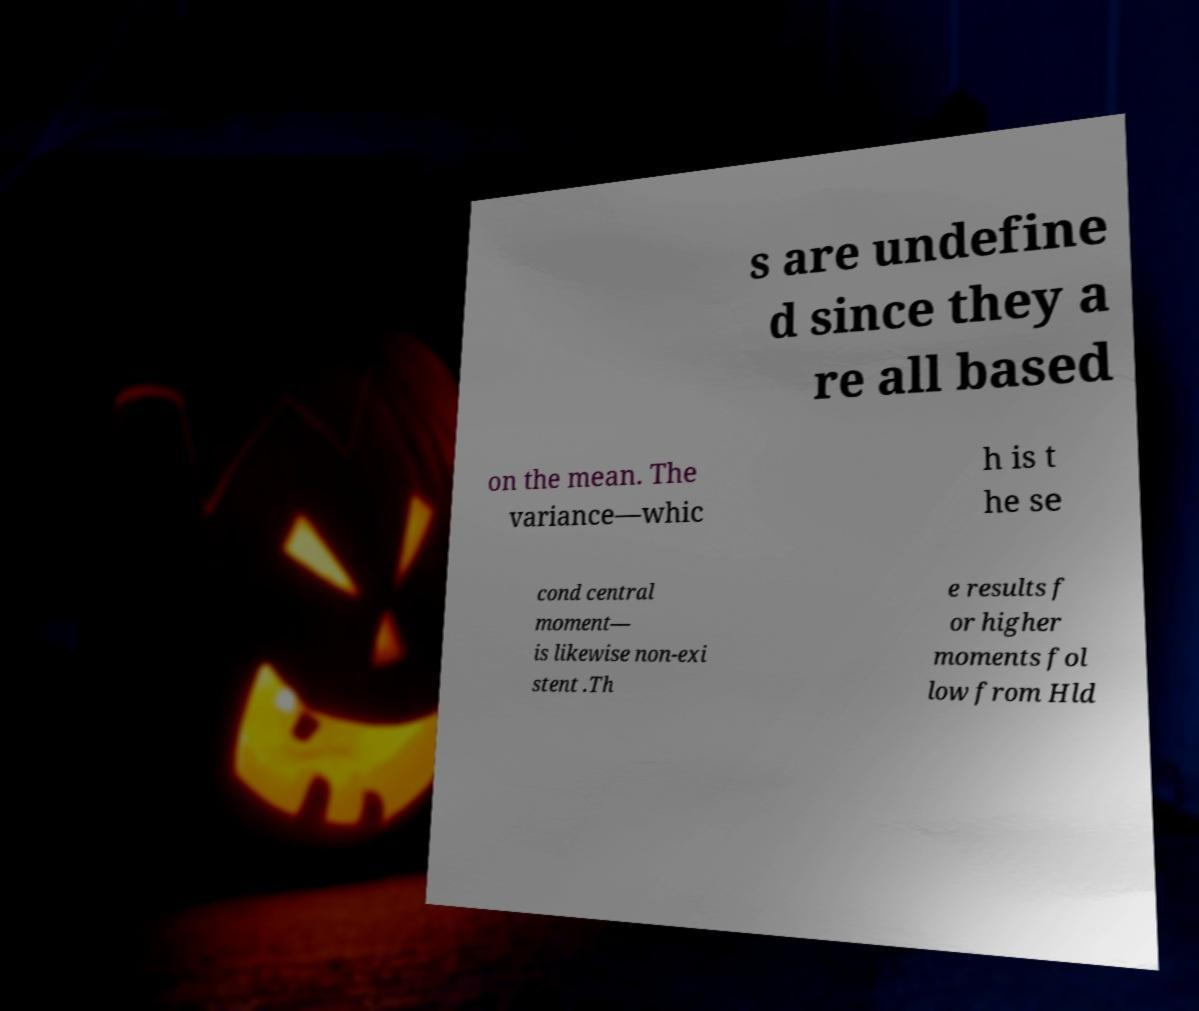There's text embedded in this image that I need extracted. Can you transcribe it verbatim? s are undefine d since they a re all based on the mean. The variance—whic h is t he se cond central moment— is likewise non-exi stent .Th e results f or higher moments fol low from Hld 